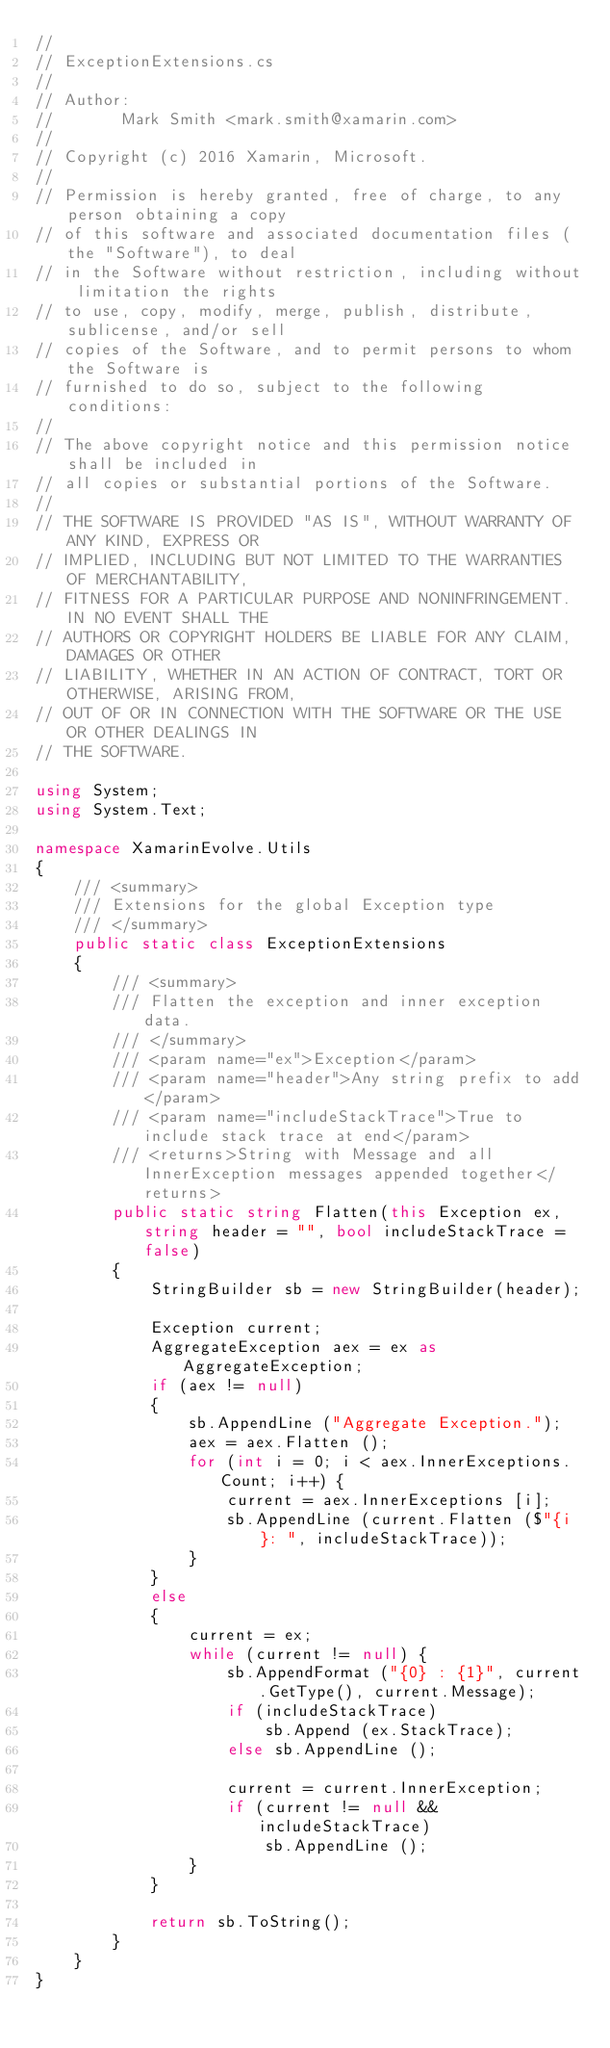<code> <loc_0><loc_0><loc_500><loc_500><_C#_>//
// ExceptionExtensions.cs
//
// Author:
//       Mark Smith <mark.smith@xamarin.com>
//
// Copyright (c) 2016 Xamarin, Microsoft.
//
// Permission is hereby granted, free of charge, to any person obtaining a copy
// of this software and associated documentation files (the "Software"), to deal
// in the Software without restriction, including without limitation the rights
// to use, copy, modify, merge, publish, distribute, sublicense, and/or sell
// copies of the Software, and to permit persons to whom the Software is
// furnished to do so, subject to the following conditions:
//
// The above copyright notice and this permission notice shall be included in
// all copies or substantial portions of the Software.
//
// THE SOFTWARE IS PROVIDED "AS IS", WITHOUT WARRANTY OF ANY KIND, EXPRESS OR
// IMPLIED, INCLUDING BUT NOT LIMITED TO THE WARRANTIES OF MERCHANTABILITY,
// FITNESS FOR A PARTICULAR PURPOSE AND NONINFRINGEMENT. IN NO EVENT SHALL THE
// AUTHORS OR COPYRIGHT HOLDERS BE LIABLE FOR ANY CLAIM, DAMAGES OR OTHER
// LIABILITY, WHETHER IN AN ACTION OF CONTRACT, TORT OR OTHERWISE, ARISING FROM,
// OUT OF OR IN CONNECTION WITH THE SOFTWARE OR THE USE OR OTHER DEALINGS IN
// THE SOFTWARE.

using System;
using System.Text;

namespace XamarinEvolve.Utils
{
    /// <summary>
    /// Extensions for the global Exception type
    /// </summary>
    public static class ExceptionExtensions
    {
        /// <summary>
        /// Flatten the exception and inner exception data.
        /// </summary>
        /// <param name="ex">Exception</param>
        /// <param name="header">Any string prefix to add</param>
        /// <param name="includeStackTrace">True to include stack trace at end</param>
        /// <returns>String with Message and all InnerException messages appended together</returns>
        public static string Flatten(this Exception ex, string header = "", bool includeStackTrace = false)
        {
            StringBuilder sb = new StringBuilder(header);

            Exception current;
            AggregateException aex = ex as AggregateException;
            if (aex != null)
            {
                sb.AppendLine ("Aggregate Exception.");
                aex = aex.Flatten ();               
                for (int i = 0; i < aex.InnerExceptions.Count; i++) {
                    current = aex.InnerExceptions [i];
                    sb.AppendLine (current.Flatten ($"{i}: ", includeStackTrace));
                }
            }
            else
            {
                current = ex;
                while (current != null) {
                    sb.AppendFormat ("{0} : {1}", current.GetType(), current.Message);
                    if (includeStackTrace)
                        sb.Append (ex.StackTrace);
                    else sb.AppendLine ();

                    current = current.InnerException;
                    if (current != null && includeStackTrace)
                        sb.AppendLine ();
                }
            }

            return sb.ToString();
        }
    }
}
</code> 